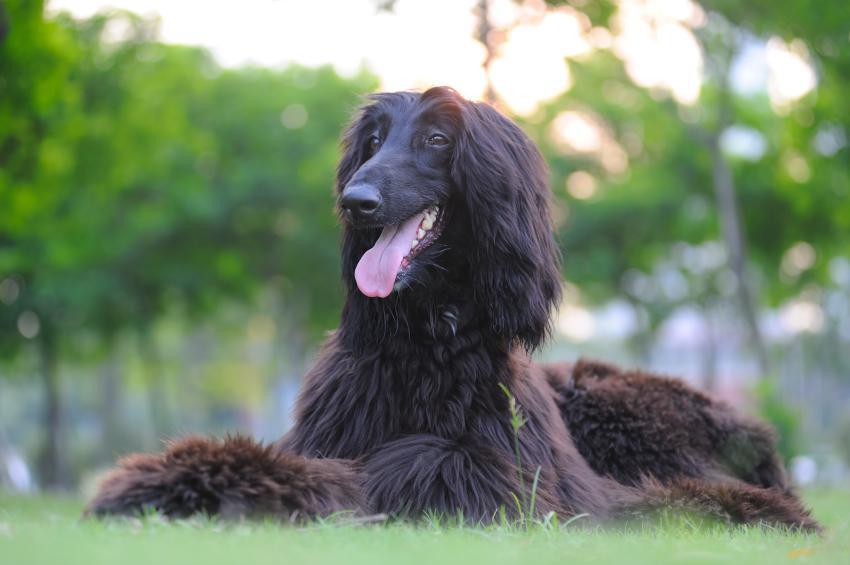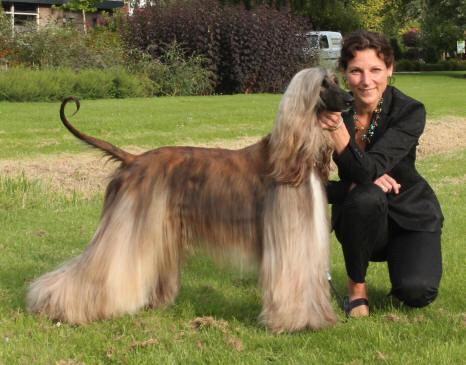The first image is the image on the left, the second image is the image on the right. Considering the images on both sides, is "There are two Afghan Hounds outside in the right image." valid? Answer yes or no. No. The first image is the image on the left, the second image is the image on the right. Evaluate the accuracy of this statement regarding the images: "One of the images contains two of the afghan hounds.". Is it true? Answer yes or no. No. 